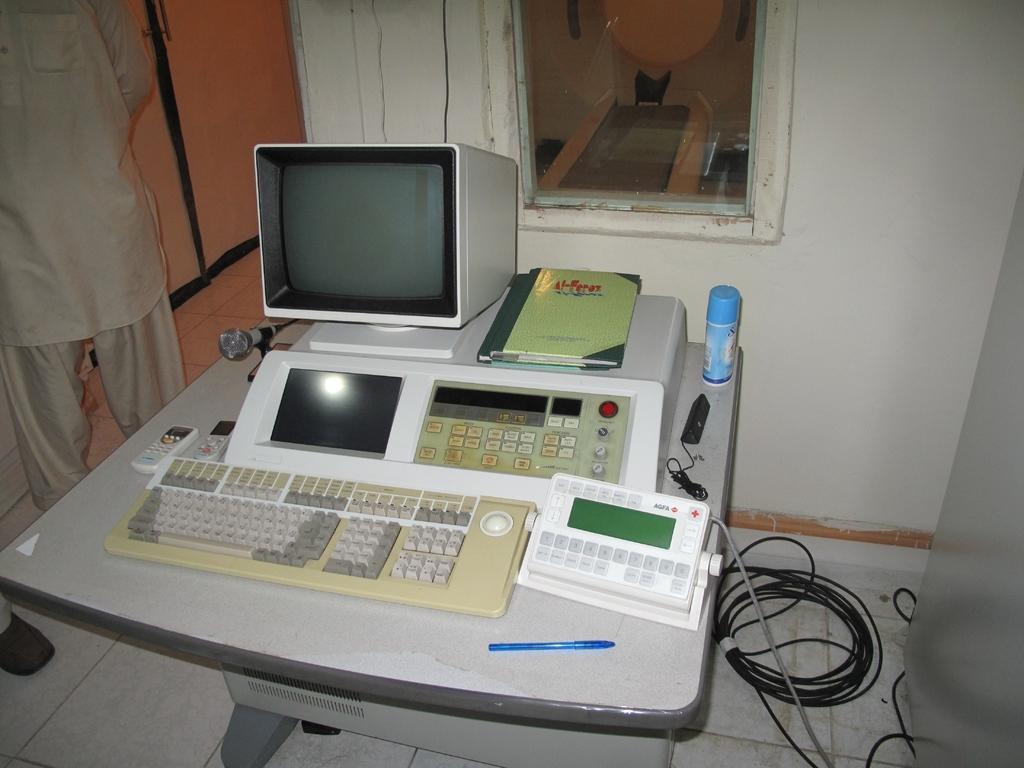Can you describe this image briefly? Here we can see a monitor, keyboard, remotes, books, bottle, pen, and devices on a table. This is floor and there are wires. Here we can see a person. In the background we can see wall and glass. 